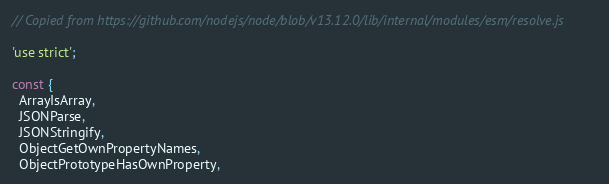<code> <loc_0><loc_0><loc_500><loc_500><_JavaScript_>// Copied from https://github.com/nodejs/node/blob/v13.12.0/lib/internal/modules/esm/resolve.js

'use strict';

const {
  ArrayIsArray,
  JSONParse,
  JSONStringify,
  ObjectGetOwnPropertyNames,
  ObjectPrototypeHasOwnProperty,</code> 